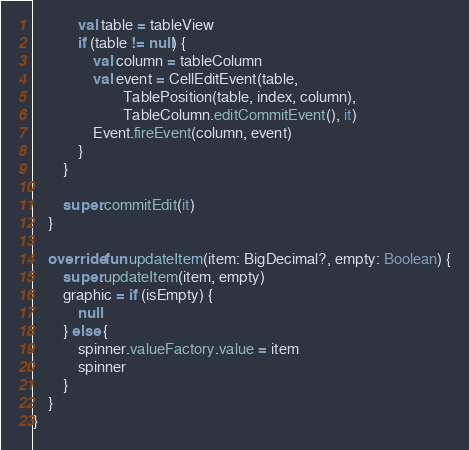Convert code to text. <code><loc_0><loc_0><loc_500><loc_500><_Kotlin_>            val table = tableView
            if (table != null) {
                val column = tableColumn
                val event = CellEditEvent(table,
                        TablePosition(table, index, column),
                        TableColumn.editCommitEvent(), it)
                Event.fireEvent(column, event)
            }
        }

        super.commitEdit(it)
    }

    override fun updateItem(item: BigDecimal?, empty: Boolean) {
        super.updateItem(item, empty)
        graphic = if (isEmpty) {
            null
        } else {
            spinner.valueFactory.value = item
            spinner
        }
    }
}</code> 